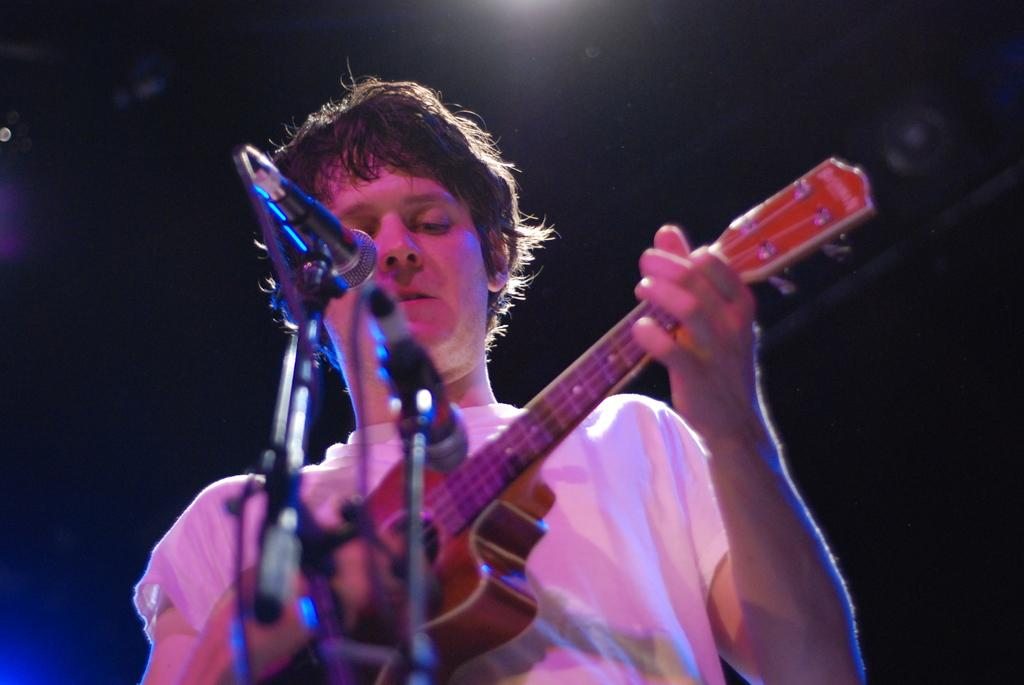What is the person in the image doing? The person is playing a guitar. What object is in front of the person? There is a microphone in front of the person. What type of jellyfish can be seen swimming near the person in the image? There are no jellyfish present in the image; it features a person playing a guitar with a microphone in front of them. 